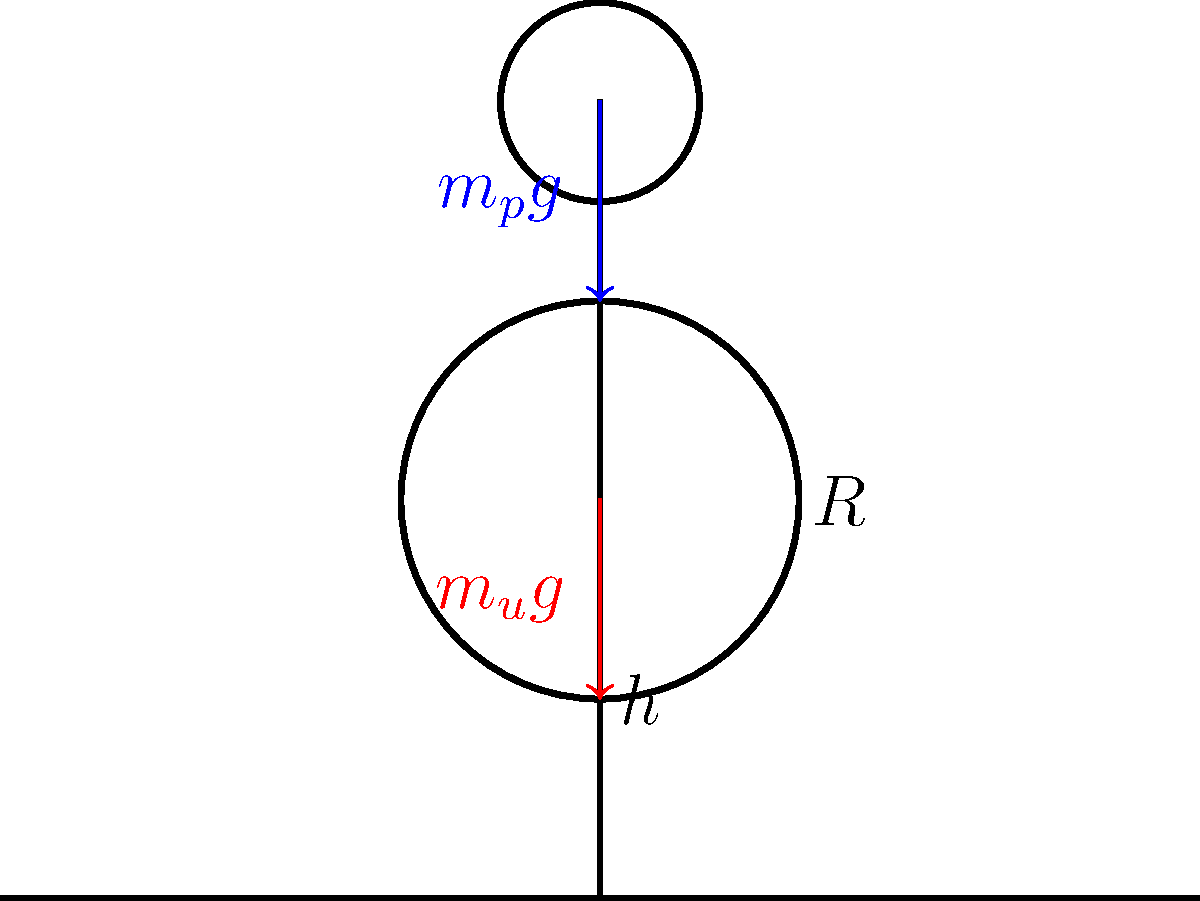A street performer balances on a unicycle, captivating your attention. The performer's mass is $m_p = 70$ kg, and the unicycle's mass is $m_u = 10$ kg. The unicycle's wheel has a radius $R = 0.5$ m, and the performer's center of mass is at a height $h = 2$ m above the ground. What is the minimum horizontal displacement of the performer's center of mass from the wheel's point of contact with the ground that will cause the unicycle to tip over? To solve this problem, we need to consider the moment of forces about the point of contact between the wheel and the ground. The unicycle will tip over when the total moment becomes zero.

Step 1: Identify the forces acting on the system.
- Weight of the performer: $F_p = m_p g$
- Weight of the unicycle: $F_u = m_u g$

Step 2: Calculate the total mass of the system.
$m_{total} = m_p + m_u = 70 + 10 = 80$ kg

Step 3: Find the height of the center of mass of the entire system.
$h_{cm} = \frac{m_p h + m_u R}{m_{total}} = \frac{70 \cdot 2 + 10 \cdot 0.5}{80} = 1.8125$ m

Step 4: Let $x$ be the horizontal displacement of the center of mass. At the point of tipping, the moment about the contact point will be zero:

$m_{total} g x = m_{total} g \cdot h_{cm}$

Step 5: Solve for $x$:
$x = h_{cm} = 1.8125$ m

Therefore, the minimum horizontal displacement that will cause the unicycle to tip over is 1.8125 m.
Answer: 1.8125 m 